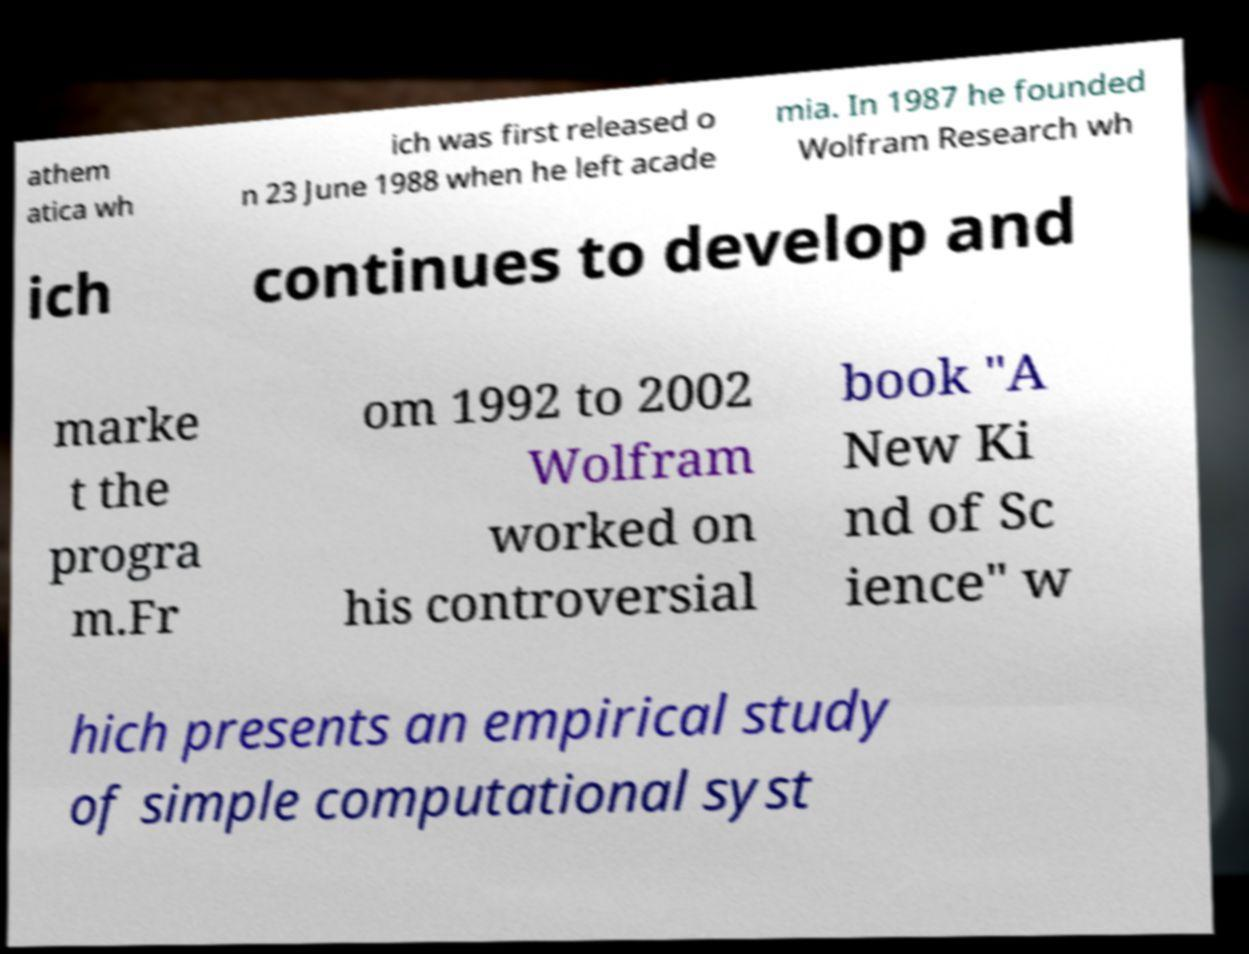Can you accurately transcribe the text from the provided image for me? athem atica wh ich was first released o n 23 June 1988 when he left acade mia. In 1987 he founded Wolfram Research wh ich continues to develop and marke t the progra m.Fr om 1992 to 2002 Wolfram worked on his controversial book "A New Ki nd of Sc ience" w hich presents an empirical study of simple computational syst 